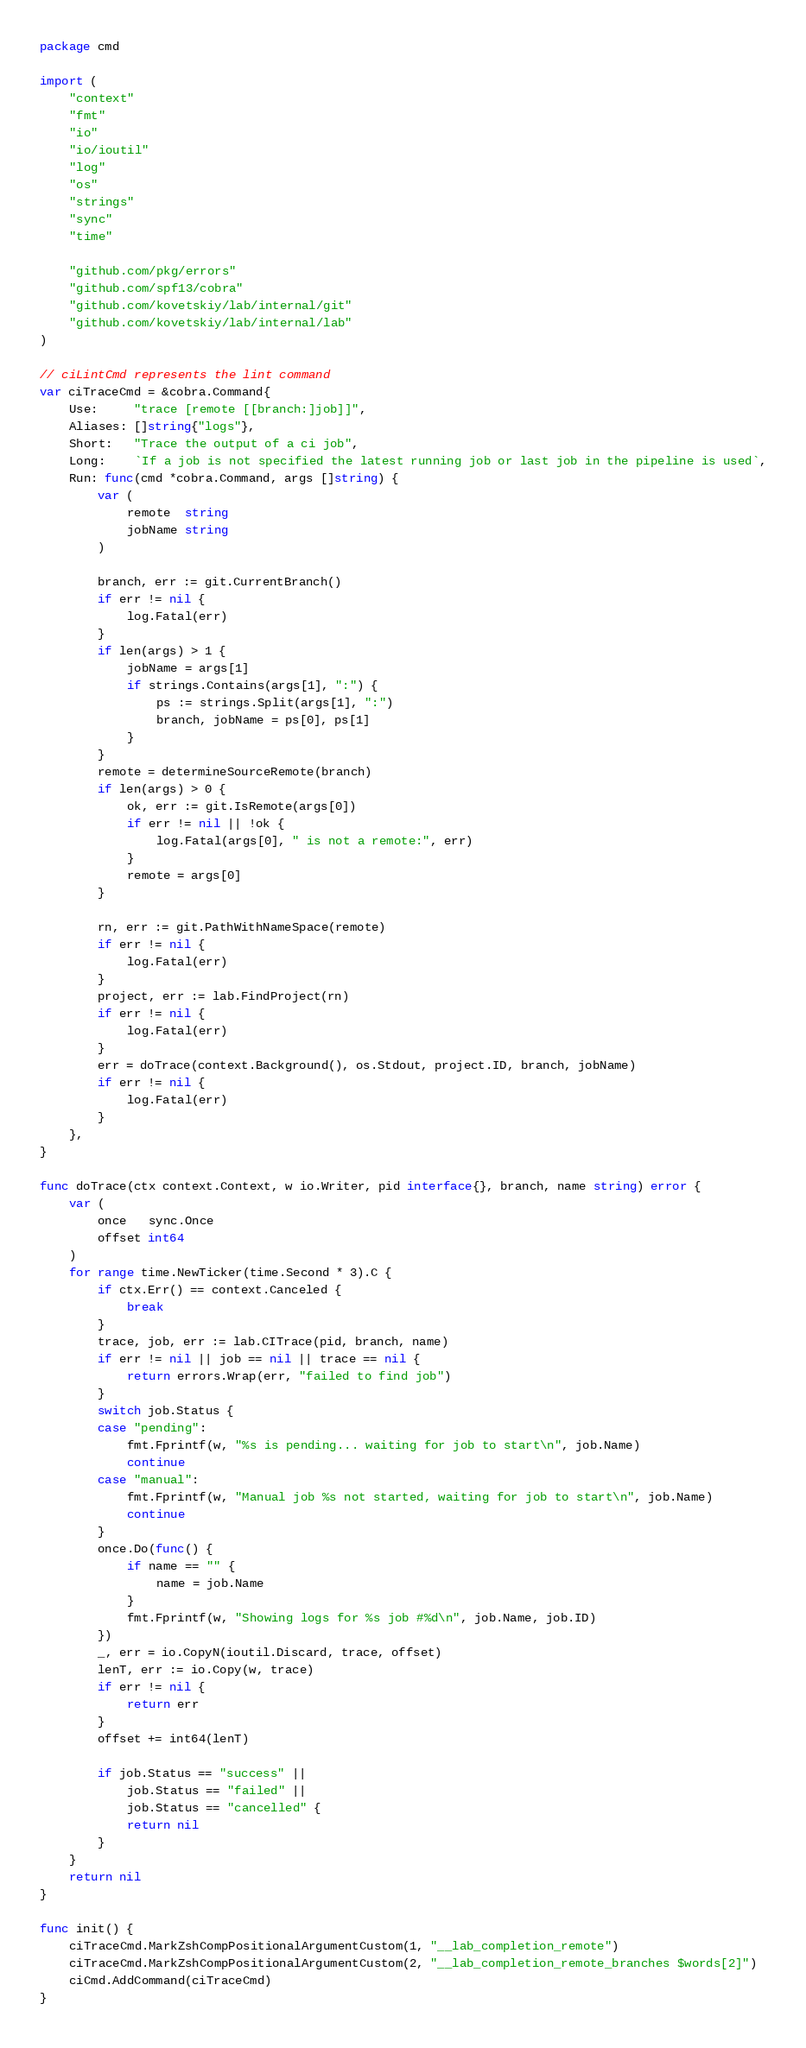Convert code to text. <code><loc_0><loc_0><loc_500><loc_500><_Go_>package cmd

import (
	"context"
	"fmt"
	"io"
	"io/ioutil"
	"log"
	"os"
	"strings"
	"sync"
	"time"

	"github.com/pkg/errors"
	"github.com/spf13/cobra"
	"github.com/kovetskiy/lab/internal/git"
	"github.com/kovetskiy/lab/internal/lab"
)

// ciLintCmd represents the lint command
var ciTraceCmd = &cobra.Command{
	Use:     "trace [remote [[branch:]job]]",
	Aliases: []string{"logs"},
	Short:   "Trace the output of a ci job",
	Long:    `If a job is not specified the latest running job or last job in the pipeline is used`,
	Run: func(cmd *cobra.Command, args []string) {
		var (
			remote  string
			jobName string
		)

		branch, err := git.CurrentBranch()
		if err != nil {
			log.Fatal(err)
		}
		if len(args) > 1 {
			jobName = args[1]
			if strings.Contains(args[1], ":") {
				ps := strings.Split(args[1], ":")
				branch, jobName = ps[0], ps[1]
			}
		}
		remote = determineSourceRemote(branch)
		if len(args) > 0 {
			ok, err := git.IsRemote(args[0])
			if err != nil || !ok {
				log.Fatal(args[0], " is not a remote:", err)
			}
			remote = args[0]
		}

		rn, err := git.PathWithNameSpace(remote)
		if err != nil {
			log.Fatal(err)
		}
		project, err := lab.FindProject(rn)
		if err != nil {
			log.Fatal(err)
		}
		err = doTrace(context.Background(), os.Stdout, project.ID, branch, jobName)
		if err != nil {
			log.Fatal(err)
		}
	},
}

func doTrace(ctx context.Context, w io.Writer, pid interface{}, branch, name string) error {
	var (
		once   sync.Once
		offset int64
	)
	for range time.NewTicker(time.Second * 3).C {
		if ctx.Err() == context.Canceled {
			break
		}
		trace, job, err := lab.CITrace(pid, branch, name)
		if err != nil || job == nil || trace == nil {
			return errors.Wrap(err, "failed to find job")
		}
		switch job.Status {
		case "pending":
			fmt.Fprintf(w, "%s is pending... waiting for job to start\n", job.Name)
			continue
		case "manual":
			fmt.Fprintf(w, "Manual job %s not started, waiting for job to start\n", job.Name)
			continue
		}
		once.Do(func() {
			if name == "" {
				name = job.Name
			}
			fmt.Fprintf(w, "Showing logs for %s job #%d\n", job.Name, job.ID)
		})
		_, err = io.CopyN(ioutil.Discard, trace, offset)
		lenT, err := io.Copy(w, trace)
		if err != nil {
			return err
		}
		offset += int64(lenT)

		if job.Status == "success" ||
			job.Status == "failed" ||
			job.Status == "cancelled" {
			return nil
		}
	}
	return nil
}

func init() {
	ciTraceCmd.MarkZshCompPositionalArgumentCustom(1, "__lab_completion_remote")
	ciTraceCmd.MarkZshCompPositionalArgumentCustom(2, "__lab_completion_remote_branches $words[2]")
	ciCmd.AddCommand(ciTraceCmd)
}
</code> 